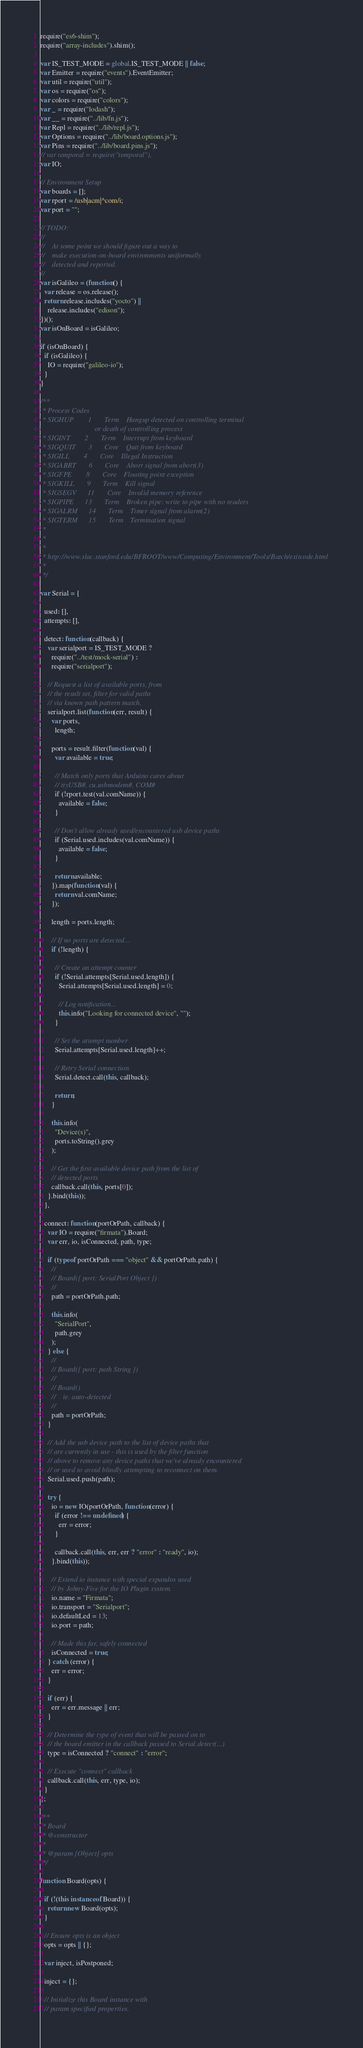Convert code to text. <code><loc_0><loc_0><loc_500><loc_500><_JavaScript_>require("es6-shim");
require("array-includes").shim();

var IS_TEST_MODE = global.IS_TEST_MODE || false;
var Emitter = require("events").EventEmitter;
var util = require("util");
var os = require("os");
var colors = require("colors");
var _ = require("lodash");
var __ = require("../lib/fn.js");
var Repl = require("../lib/repl.js");
var Options = require("../lib/board.options.js");
var Pins = require("../lib/board.pins.js");
// var temporal = require("temporal"),
var IO;

// Environment Setup
var boards = [];
var rport = /usb|acm|^com/i;
var port = "";

// TODO:
//
//    At some point we should figure out a way to
//    make execution-on-board environments uniformally
//    detected and reported.
//
var isGalileo = (function() {
  var release = os.release();
  return release.includes("yocto") ||
    release.includes("edison");
})();
var isOnBoard = isGalileo;

if (isOnBoard) {
  if (isGalileo) {
    IO = require("galileo-io");
  }
}

/**
 * Process Codes
 * SIGHUP        1       Term    Hangup detected on controlling terminal
                              or death of controlling process
 * SIGINT        2       Term    Interrupt from keyboard
 * SIGQUIT       3       Core    Quit from keyboard
 * SIGILL        4       Core    Illegal Instruction
 * SIGABRT       6       Core    Abort signal from abort(3)
 * SIGFPE        8       Core    Floating point exception
 * SIGKILL       9       Term    Kill signal
 * SIGSEGV      11       Core    Invalid memory reference
 * SIGPIPE      13       Term    Broken pipe: write to pipe with no readers
 * SIGALRM      14       Term    Timer signal from alarm(2)
 * SIGTERM      15       Term    Termination signal
 *
 *
 *
 * http://www.slac.stanford.edu/BFROOT/www/Computing/Environment/Tools/Batch/exitcode.html
 *
 */

var Serial = {

  used: [],
  attempts: [],

  detect: function(callback) {
    var serialport = IS_TEST_MODE ?
      require("../test/mock-serial") :
      require("serialport");

    // Request a list of available ports, from
    // the result set, filter for valid paths
    // via known path pattern match.
    serialport.list(function(err, result) {
      var ports,
        length;

      ports = result.filter(function(val) {
        var available = true;

        // Match only ports that Arduino cares about
        // ttyUSB#, cu.usbmodem#, COM#
        if (!rport.test(val.comName)) {
          available = false;
        }

        // Don't allow already used/encountered usb device paths
        if (Serial.used.includes(val.comName)) {
          available = false;
        }

        return available;
      }).map(function(val) {
        return val.comName;
      });

      length = ports.length;

      // If no ports are detected...
      if (!length) {

        // Create an attempt counter
        if (!Serial.attempts[Serial.used.length]) {
          Serial.attempts[Serial.used.length] = 0;

          // Log notification...
          this.info("Looking for connected device", "");
        }

        // Set the attempt number
        Serial.attempts[Serial.used.length]++;

        // Retry Serial connection
        Serial.detect.call(this, callback);

        return;
      }

      this.info(
        "Device(s)",
        ports.toString().grey
      );

      // Get the first available device path from the list of
      // detected ports
      callback.call(this, ports[0]);
    }.bind(this));
  },

  connect: function(portOrPath, callback) {
    var IO = require("firmata").Board;
    var err, io, isConnected, path, type;

    if (typeof portOrPath === "object" && portOrPath.path) {
      //
      // Board({ port: SerialPort Object })
      //
      path = portOrPath.path;

      this.info(
        "SerialPort",
        path.grey
      );
    } else {
      //
      // Board({ port: path String })
      //
      // Board()
      //    ie. auto-detected
      //
      path = portOrPath;
    }

    // Add the usb device path to the list of device paths that
    // are currently in use - this is used by the filter function
    // above to remove any device paths that we've already encountered
    // or used to avoid blindly attempting to reconnect on them.
    Serial.used.push(path);

    try {
      io = new IO(portOrPath, function(error) {
        if (error !== undefined) {
          err = error;
        }

        callback.call(this, err, err ? "error" : "ready", io);
      }.bind(this));

      // Extend io instance with special expandos used
      // by Johny-Five for the IO Plugin system.
      io.name = "Firmata";
      io.transport = "Serialport";
      io.defaultLed = 13;
      io.port = path;

      // Made this far, safely connected
      isConnected = true;
    } catch (error) {
      err = error;
    }

    if (err) {
      err = err.message || err;
    }

    // Determine the type of event that will be passed on to
    // the board emitter in the callback passed to Serial.detect(...)
    type = isConnected ? "connect" : "error";

    // Execute "connect" callback
    callback.call(this, err, type, io);
  }
};

/**
 * Board
 * @constructor
 *
 * @param {Object} opts
 */

function Board(opts) {

  if (!(this instanceof Board)) {
    return new Board(opts);
  }

  // Ensure opts is an object
  opts = opts || {};

  var inject, isPostponed;

  inject = {};

  // Initialize this Board instance with
  // param specified properties.</code> 